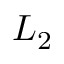Convert formula to latex. <formula><loc_0><loc_0><loc_500><loc_500>L _ { 2 }</formula> 